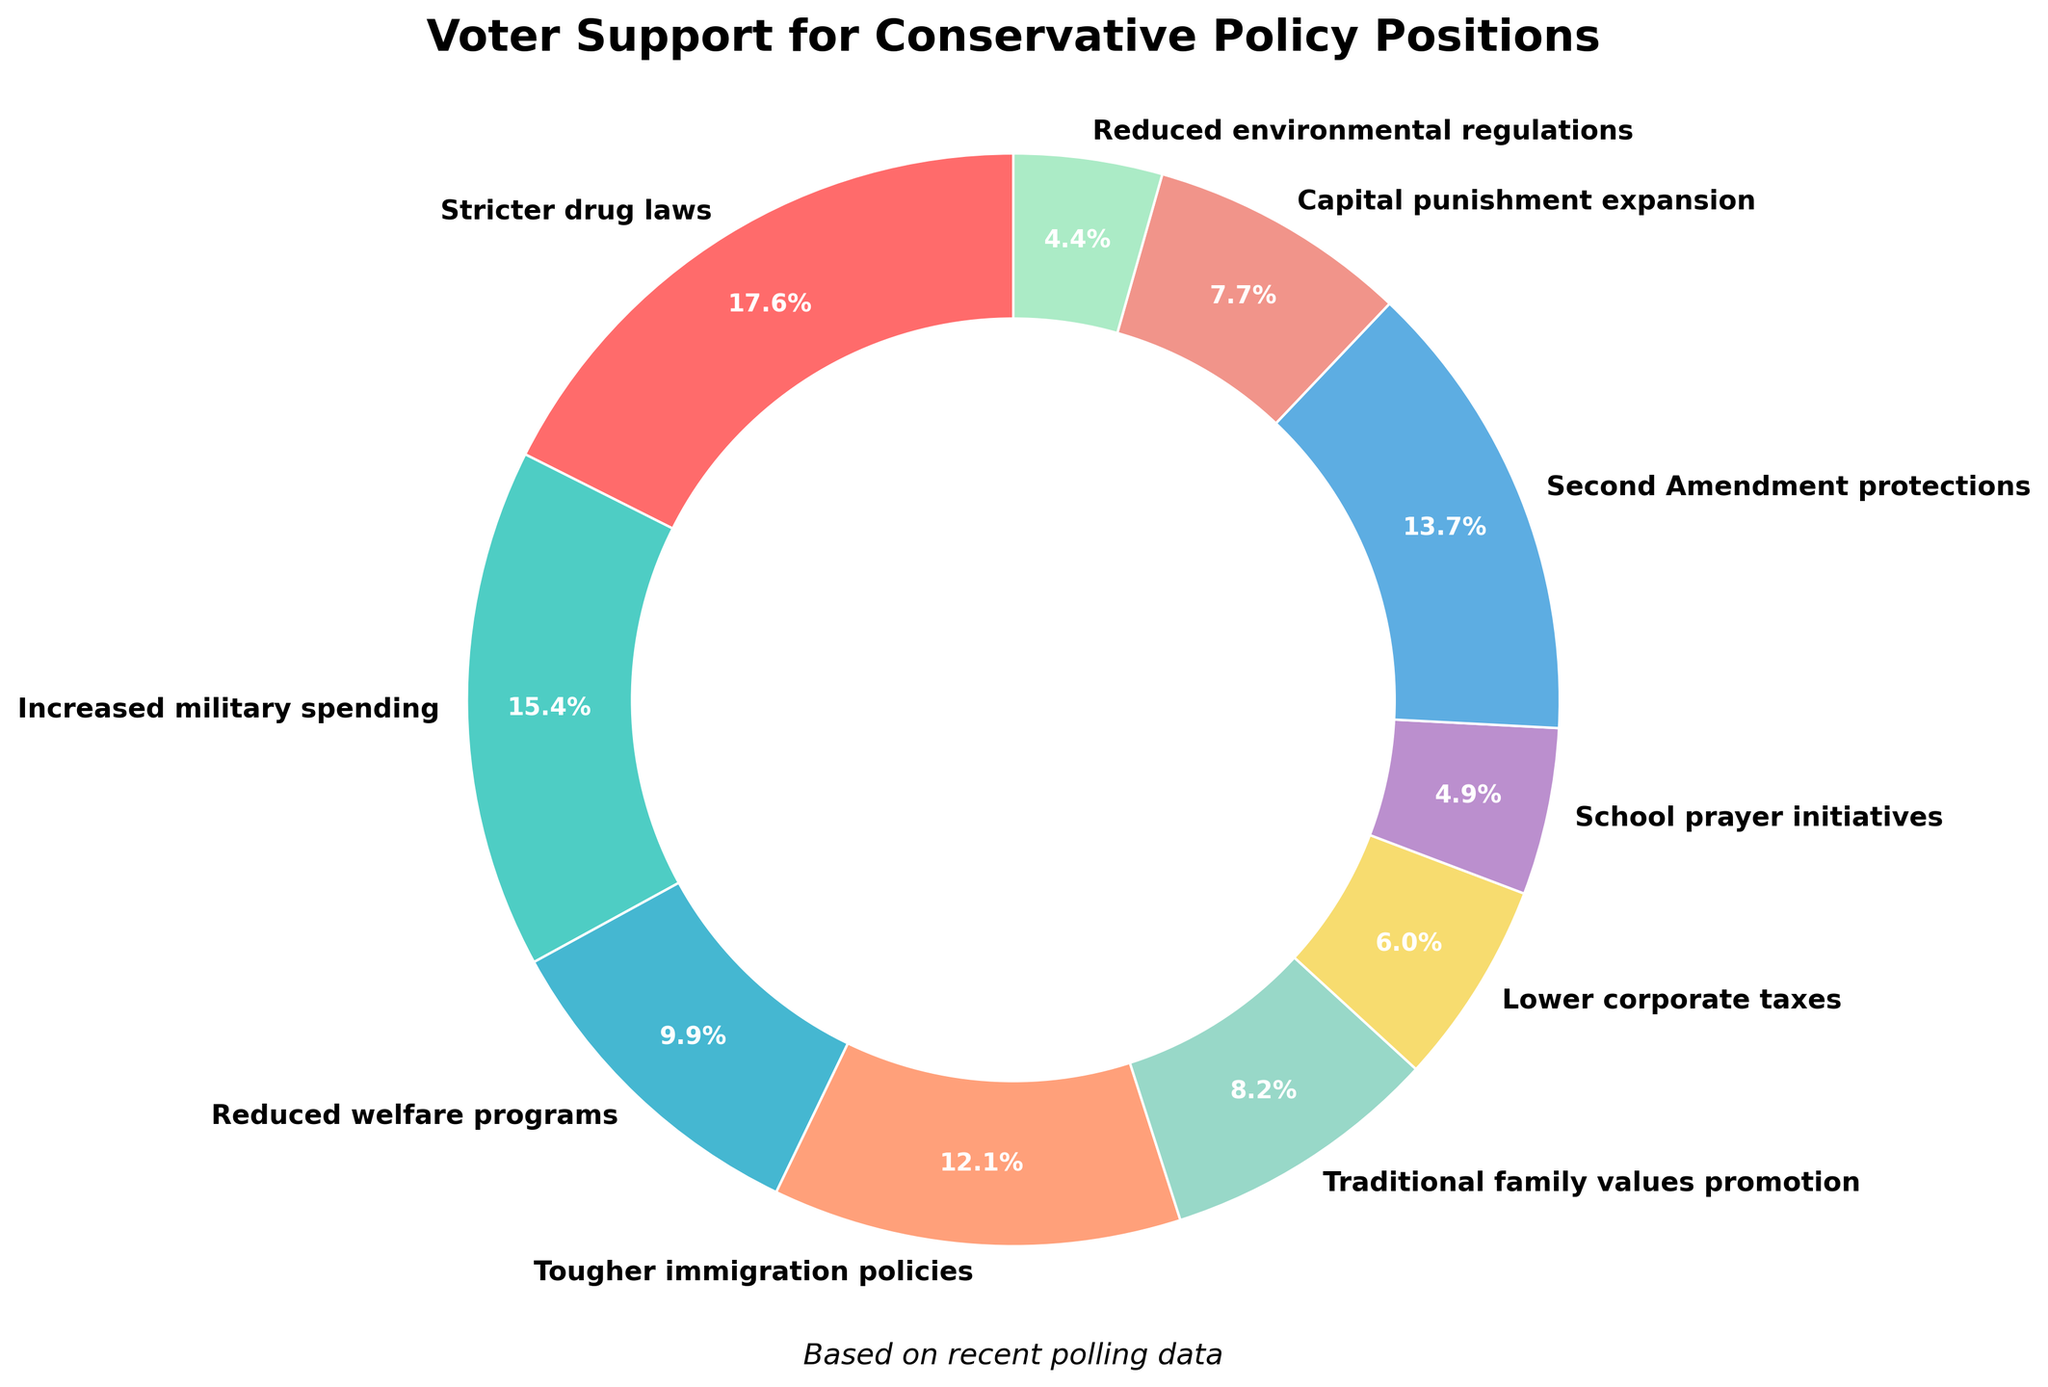How much support do Stricter drug laws and Tougher immigration policies have combined? To find the combined support for Stricter drug laws and Tougher immigration policies, add their respective support percentages. Stricter drug laws have 32% support, and Tougher immigration policies have 22% support. So, the combined support is 32% + 22% = 54%.
Answer: 54% Which policy has higher support: Increased military spending or Second Amendment protections? Compare the support percentages of Increased military spending and Second Amendment protections. Increased military spending has 28% support, while Second Amendment protections have 25% support. Therefore, Increased military spending has higher support.
Answer: Increased military spending What is the difference in support between Reduced welfare programs and Traditional family values promotion? Subtract the support percentage of Traditional family values promotion from Reduced welfare programs. Reduced welfare programs have 18% support, and Traditional family values promotion has 15% support. The difference is 18% - 15% = 3%.
Answer: 3% Which policy position has the least voter support? Identify the policy with the lowest support percentage by scanning the pie chart. Reduced environmental regulations have the least voter support at 8%.
Answer: Reduced environmental regulations What is the total voter support for initiatives related to societal values (Traditional family values promotion and School prayer initiatives)? Add the support percentages for Traditional family values promotion and School prayer initiatives. Traditional family values promotion has 15% support and School prayer initiatives have 9% support. Therefore, the total is 15% + 9% = 24%.
Answer: 24% How does support for Capital punishment expansion compare to that for Lower corporate taxes? Compare the support percentages for Capital punishment expansion and Lower corporate taxes. Capital punishment expansion has 14% support, while Lower corporate taxes have 11% support. Capital punishment expansion has higher support.
Answer: Capital punishment expansion Which policy position has a blue wedge in the chart? Identify the wedge colored blue in the pie chart. The blue wedge represents Second Amendment protections.
Answer: Second Amendment protections What percentage of support does the policy with the red wedge have? Identify the wedge colored red in the pie chart to find its associated policy and support percentage. The red wedge represents Stricter drug laws, which have 32% support.
Answer: 32% If you combine support for Lower corporate taxes, School prayer initiatives, and Reduced environmental regulations, does their combined support exceed 25%? Add the support percentages for Lower corporate taxes, School prayer initiatives, and Reduced environmental regulations. Lower corporate taxes have 11% support, School prayer initiatives have 9% support, and Reduced environmental regulations have 8% support. Their combined support is 11% + 9% + 8% = 28%, which exceeds 25%.
Answer: Yes Which has greater support, Reduced welfare programs or the combined support for School prayer initiatives and Reduced environmental regulations? First, calculate the combined support for School prayer initiatives and Reduced environmental regulations: 9% + 8% = 17%. Then, compare this to the support for Reduced welfare programs which is 18%. Reduced welfare programs have greater support.
Answer: Reduced welfare programs 